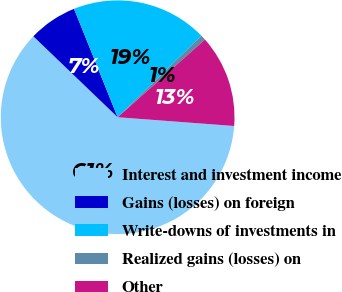Convert chart to OTSL. <chart><loc_0><loc_0><loc_500><loc_500><pie_chart><fcel>Interest and investment income<fcel>Gains (losses) on foreign<fcel>Write-downs of investments in<fcel>Realized gains (losses) on<fcel>Other<nl><fcel>60.98%<fcel>6.74%<fcel>18.79%<fcel>0.72%<fcel>12.77%<nl></chart> 